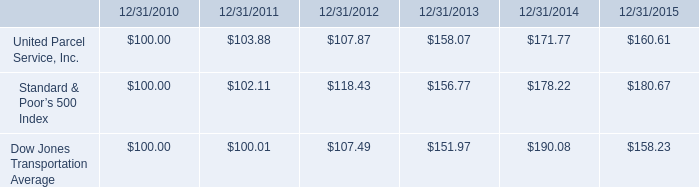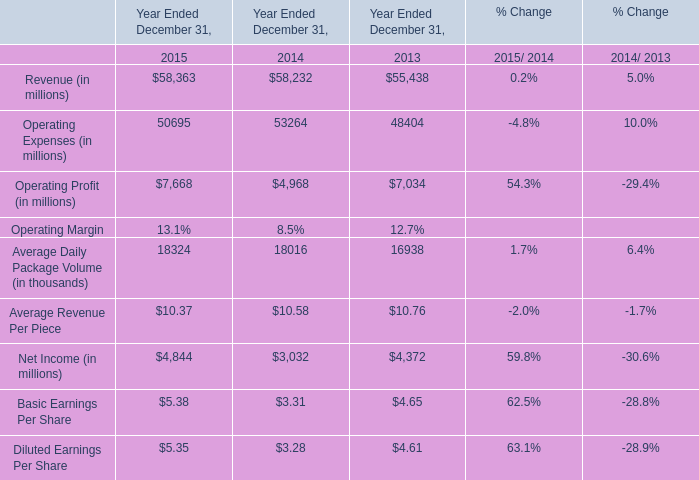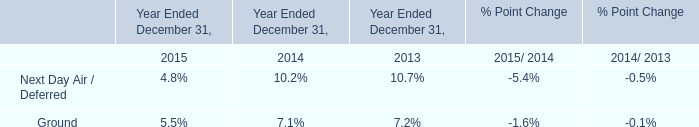Which year is Operating Profit (in millions) the lowest? 
Answer: 2014. 